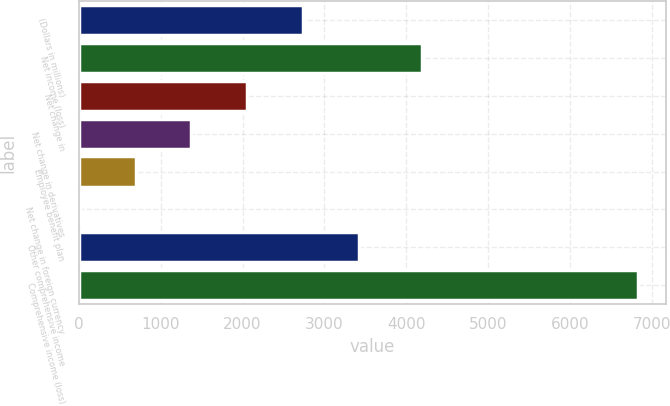Convert chart to OTSL. <chart><loc_0><loc_0><loc_500><loc_500><bar_chart><fcel>(Dollars in millions)<fcel>Net income (loss)<fcel>Net change in<fcel>Net change in derivatives<fcel>Employee benefit plan<fcel>Net change in foreign currency<fcel>Other comprehensive income<fcel>Comprehensive income (loss)<nl><fcel>2739<fcel>4188<fcel>2057.5<fcel>1376<fcel>694.5<fcel>13<fcel>3420.5<fcel>6828<nl></chart> 